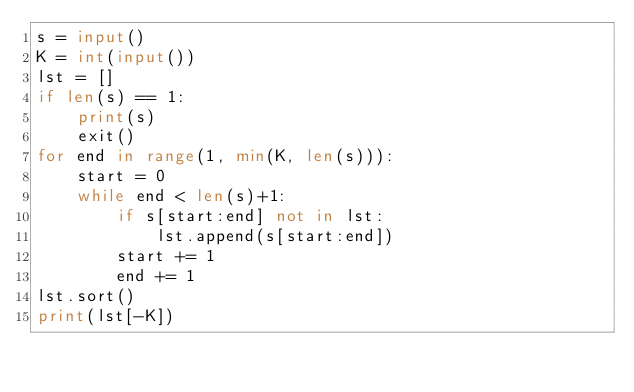<code> <loc_0><loc_0><loc_500><loc_500><_Python_>s = input()
K = int(input())
lst = []
if len(s) == 1:
    print(s)
    exit()
for end in range(1, min(K, len(s))):
    start = 0
    while end < len(s)+1:
        if s[start:end] not in lst:
            lst.append(s[start:end])
        start += 1
        end += 1
lst.sort()
print(lst[-K])</code> 